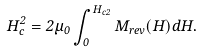Convert formula to latex. <formula><loc_0><loc_0><loc_500><loc_500>H ^ { 2 } _ { c } = 2 \mu _ { 0 } \int _ { 0 } ^ { H _ { c 2 } } M _ { r e v } ( H ) d H .</formula> 